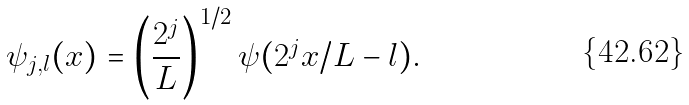<formula> <loc_0><loc_0><loc_500><loc_500>\psi _ { j , l } ( x ) = \left ( \frac { 2 ^ { j } } { L } \right ) ^ { 1 / 2 } \psi ( 2 ^ { j } x / L - l ) .</formula> 